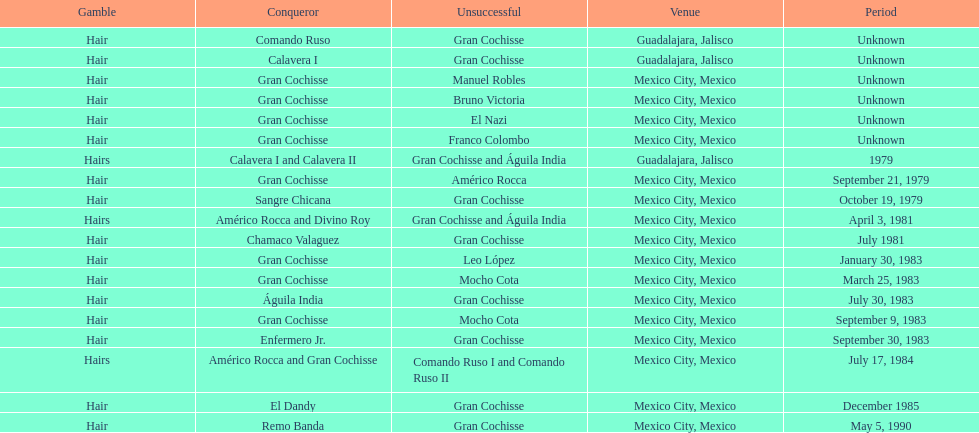How many games more than chamaco valaguez did sangre chicana win? 0. 